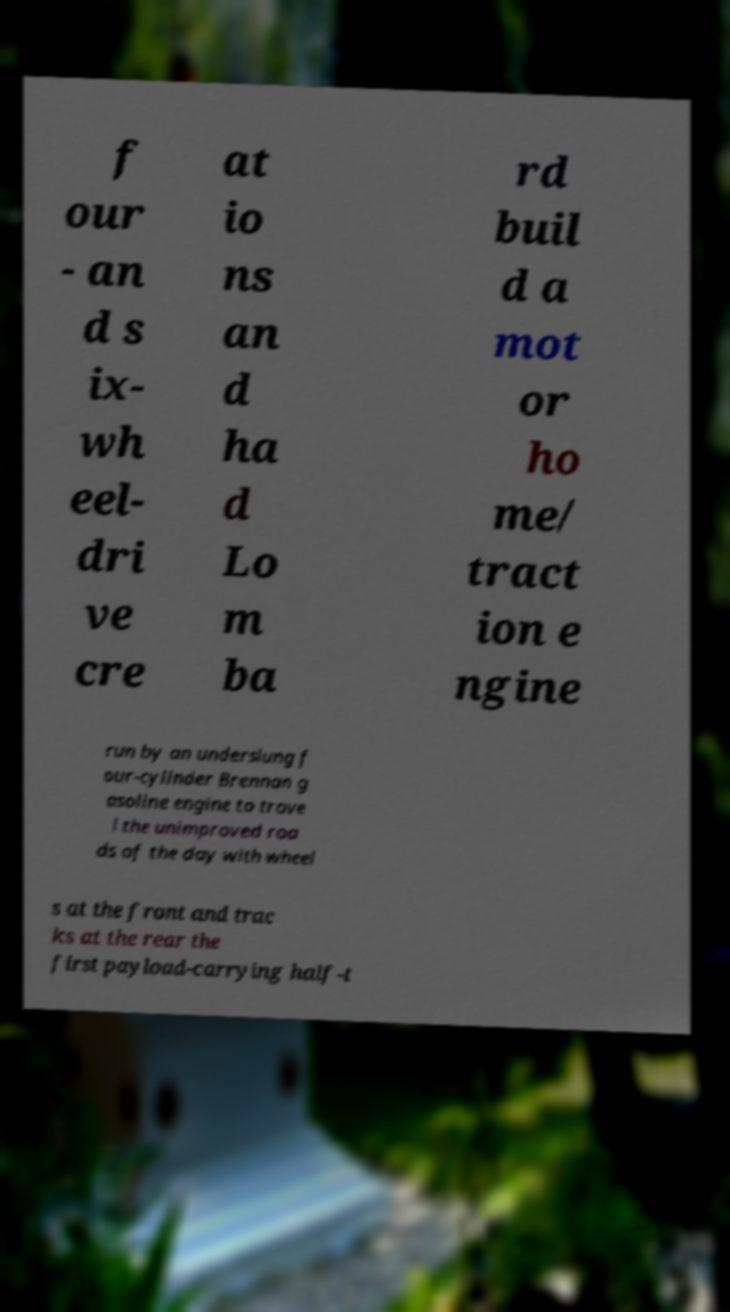Can you accurately transcribe the text from the provided image for me? f our - an d s ix- wh eel- dri ve cre at io ns an d ha d Lo m ba rd buil d a mot or ho me/ tract ion e ngine run by an underslung f our-cylinder Brennan g asoline engine to trave l the unimproved roa ds of the day with wheel s at the front and trac ks at the rear the first payload-carrying half-t 